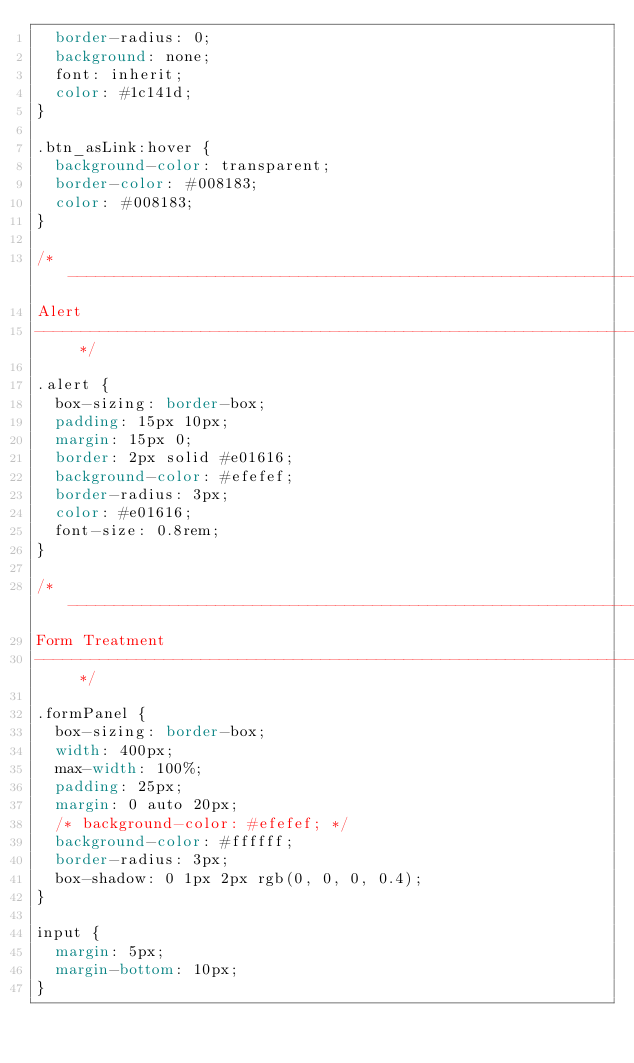<code> <loc_0><loc_0><loc_500><loc_500><_CSS_>  border-radius: 0;
  background: none;
  font: inherit;
  color: #1c141d;
}

.btn_asLink:hover {
  background-color: transparent;
  border-color: #008183;
  color: #008183;
}

/* --------------------------------------------------------------------------------
Alert
-------------------------------------------------------------------------------- */

.alert {
  box-sizing: border-box;
  padding: 15px 10px;
  margin: 15px 0;
  border: 2px solid #e01616;
  background-color: #efefef;
  border-radius: 3px;
  color: #e01616;
  font-size: 0.8rem;
}

/* --------------------------------------------------------------------------------
Form Treatment
-------------------------------------------------------------------------------- */

.formPanel {
  box-sizing: border-box;
  width: 400px;
  max-width: 100%;
  padding: 25px;
  margin: 0 auto 20px;
  /* background-color: #efefef; */
  background-color: #ffffff;
  border-radius: 3px;
  box-shadow: 0 1px 2px rgb(0, 0, 0, 0.4);
}

input {
  margin: 5px;
  margin-bottom: 10px;
}
</code> 